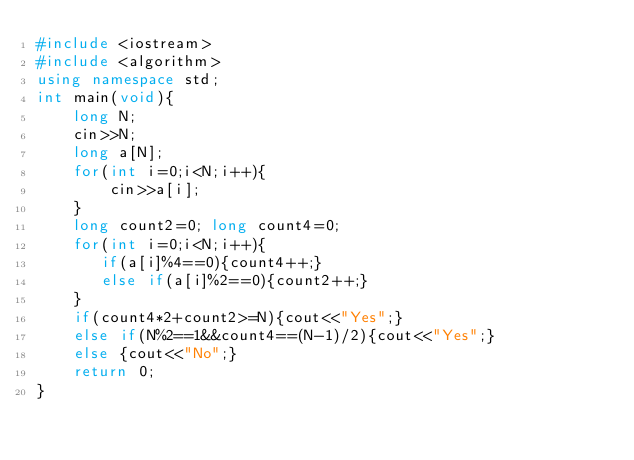Convert code to text. <code><loc_0><loc_0><loc_500><loc_500><_C++_>#include <iostream>
#include <algorithm>
using namespace std;
int main(void){
    long N;
    cin>>N;
    long a[N];
    for(int i=0;i<N;i++){
        cin>>a[i];
    }
    long count2=0; long count4=0;
    for(int i=0;i<N;i++){
       if(a[i]%4==0){count4++;}
       else if(a[i]%2==0){count2++;}
    }
    if(count4*2+count2>=N){cout<<"Yes";}
    else if(N%2==1&&count4==(N-1)/2){cout<<"Yes";}
    else {cout<<"No";}
    return 0;
}
</code> 